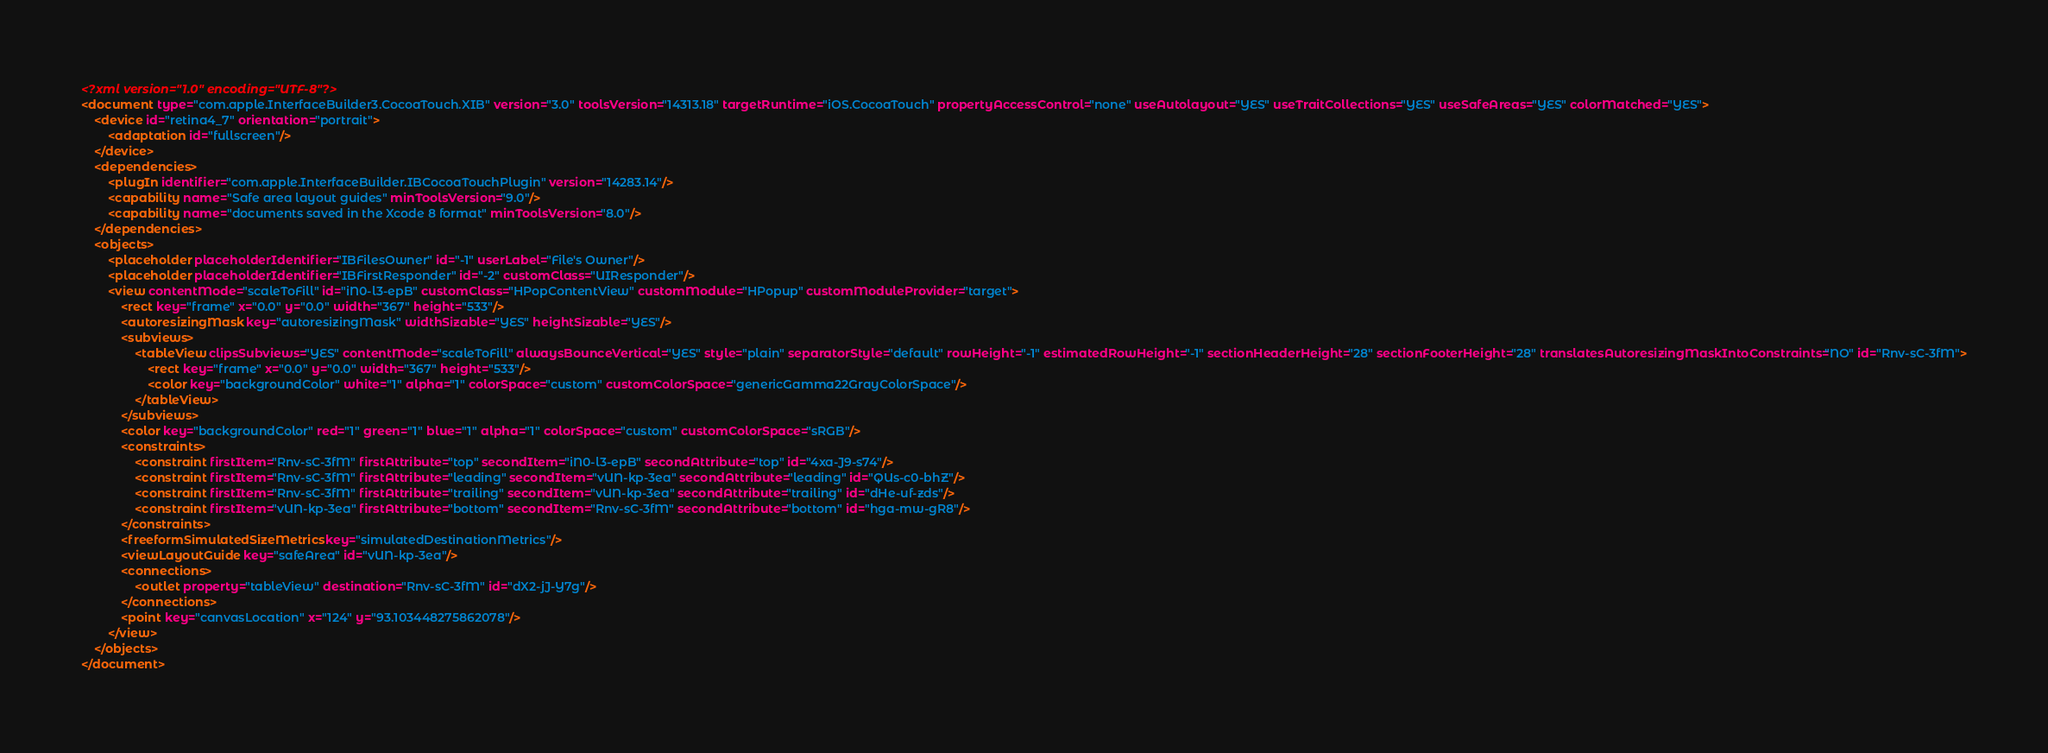<code> <loc_0><loc_0><loc_500><loc_500><_XML_><?xml version="1.0" encoding="UTF-8"?>
<document type="com.apple.InterfaceBuilder3.CocoaTouch.XIB" version="3.0" toolsVersion="14313.18" targetRuntime="iOS.CocoaTouch" propertyAccessControl="none" useAutolayout="YES" useTraitCollections="YES" useSafeAreas="YES" colorMatched="YES">
    <device id="retina4_7" orientation="portrait">
        <adaptation id="fullscreen"/>
    </device>
    <dependencies>
        <plugIn identifier="com.apple.InterfaceBuilder.IBCocoaTouchPlugin" version="14283.14"/>
        <capability name="Safe area layout guides" minToolsVersion="9.0"/>
        <capability name="documents saved in the Xcode 8 format" minToolsVersion="8.0"/>
    </dependencies>
    <objects>
        <placeholder placeholderIdentifier="IBFilesOwner" id="-1" userLabel="File's Owner"/>
        <placeholder placeholderIdentifier="IBFirstResponder" id="-2" customClass="UIResponder"/>
        <view contentMode="scaleToFill" id="iN0-l3-epB" customClass="HPopContentView" customModule="HPopup" customModuleProvider="target">
            <rect key="frame" x="0.0" y="0.0" width="367" height="533"/>
            <autoresizingMask key="autoresizingMask" widthSizable="YES" heightSizable="YES"/>
            <subviews>
                <tableView clipsSubviews="YES" contentMode="scaleToFill" alwaysBounceVertical="YES" style="plain" separatorStyle="default" rowHeight="-1" estimatedRowHeight="-1" sectionHeaderHeight="28" sectionFooterHeight="28" translatesAutoresizingMaskIntoConstraints="NO" id="Rnv-sC-3fM">
                    <rect key="frame" x="0.0" y="0.0" width="367" height="533"/>
                    <color key="backgroundColor" white="1" alpha="1" colorSpace="custom" customColorSpace="genericGamma22GrayColorSpace"/>
                </tableView>
            </subviews>
            <color key="backgroundColor" red="1" green="1" blue="1" alpha="1" colorSpace="custom" customColorSpace="sRGB"/>
            <constraints>
                <constraint firstItem="Rnv-sC-3fM" firstAttribute="top" secondItem="iN0-l3-epB" secondAttribute="top" id="4xa-J9-s74"/>
                <constraint firstItem="Rnv-sC-3fM" firstAttribute="leading" secondItem="vUN-kp-3ea" secondAttribute="leading" id="QUs-c0-bhZ"/>
                <constraint firstItem="Rnv-sC-3fM" firstAttribute="trailing" secondItem="vUN-kp-3ea" secondAttribute="trailing" id="dHe-uf-zds"/>
                <constraint firstItem="vUN-kp-3ea" firstAttribute="bottom" secondItem="Rnv-sC-3fM" secondAttribute="bottom" id="hga-mw-gR8"/>
            </constraints>
            <freeformSimulatedSizeMetrics key="simulatedDestinationMetrics"/>
            <viewLayoutGuide key="safeArea" id="vUN-kp-3ea"/>
            <connections>
                <outlet property="tableView" destination="Rnv-sC-3fM" id="dX2-jJ-Y7g"/>
            </connections>
            <point key="canvasLocation" x="124" y="93.103448275862078"/>
        </view>
    </objects>
</document>
</code> 